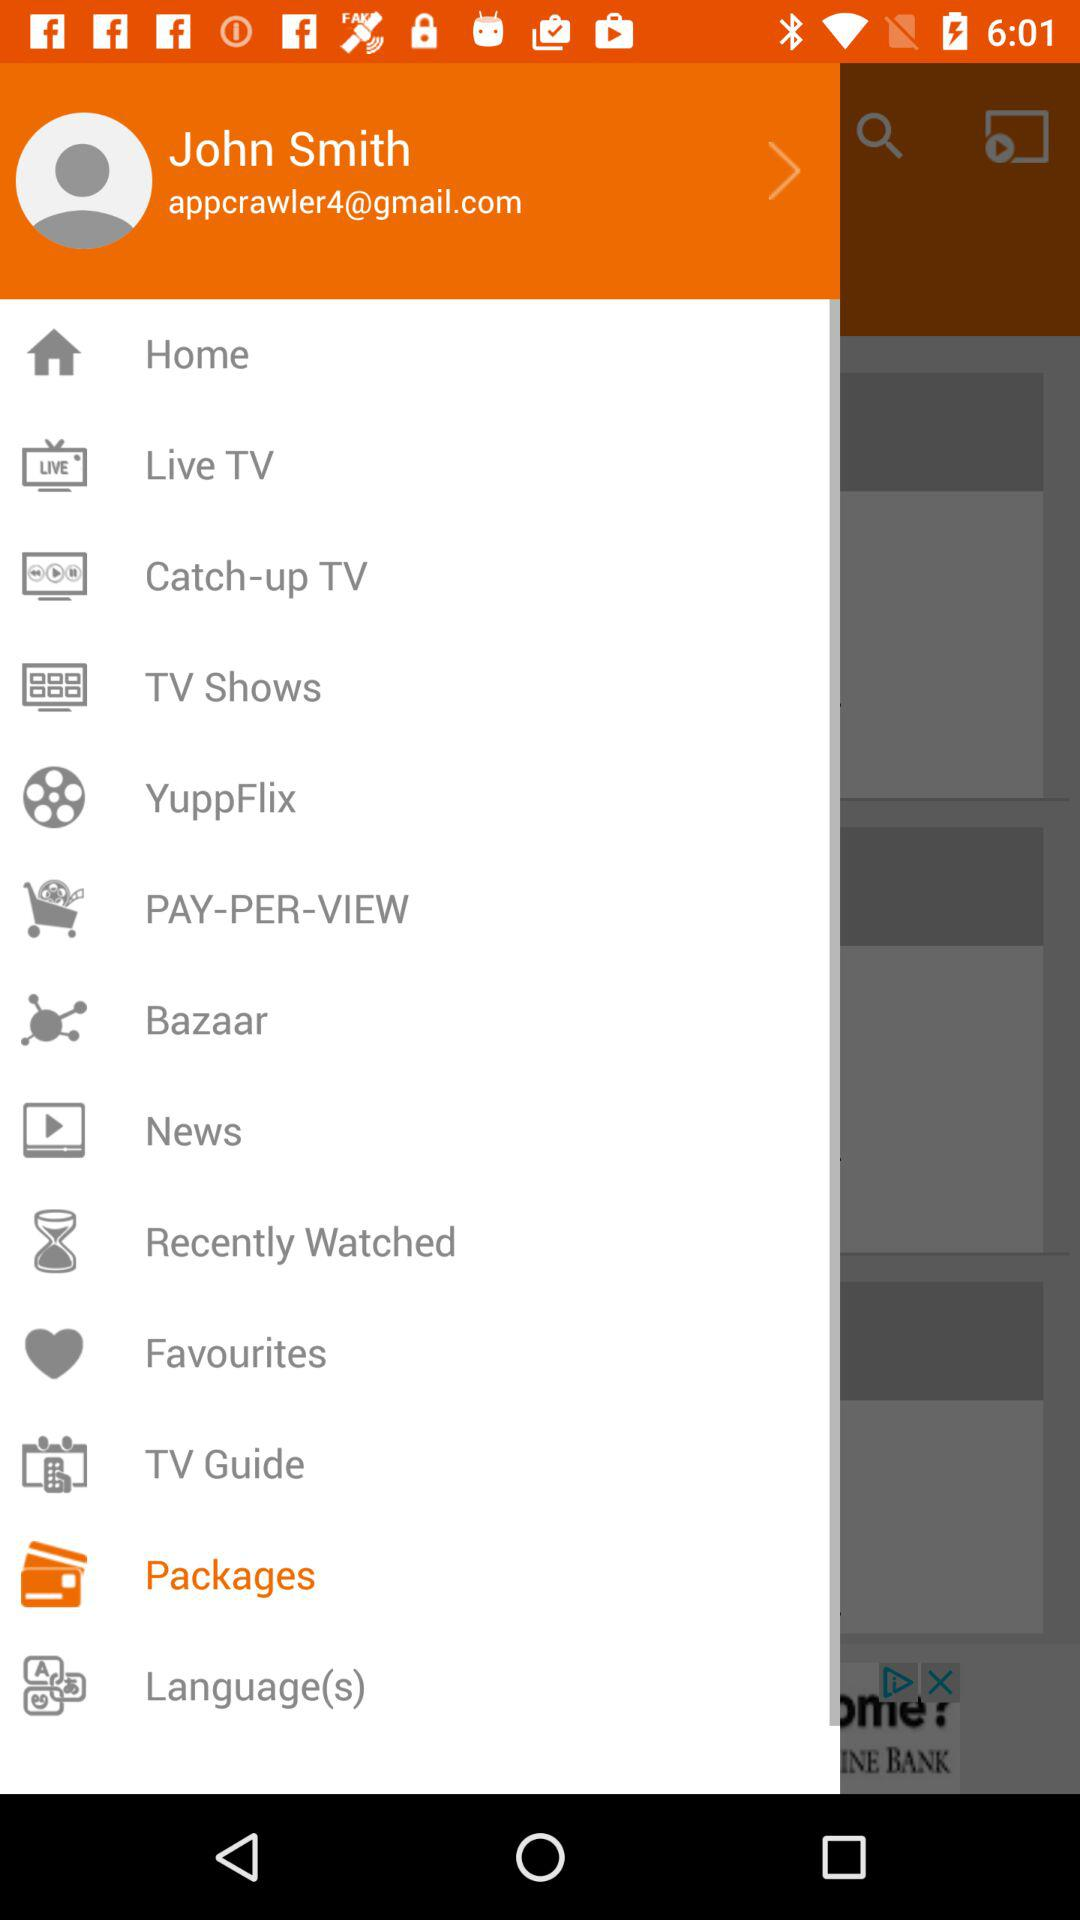What's the Gmail address? The Gmail address is appcrawler4@gmail.com. 